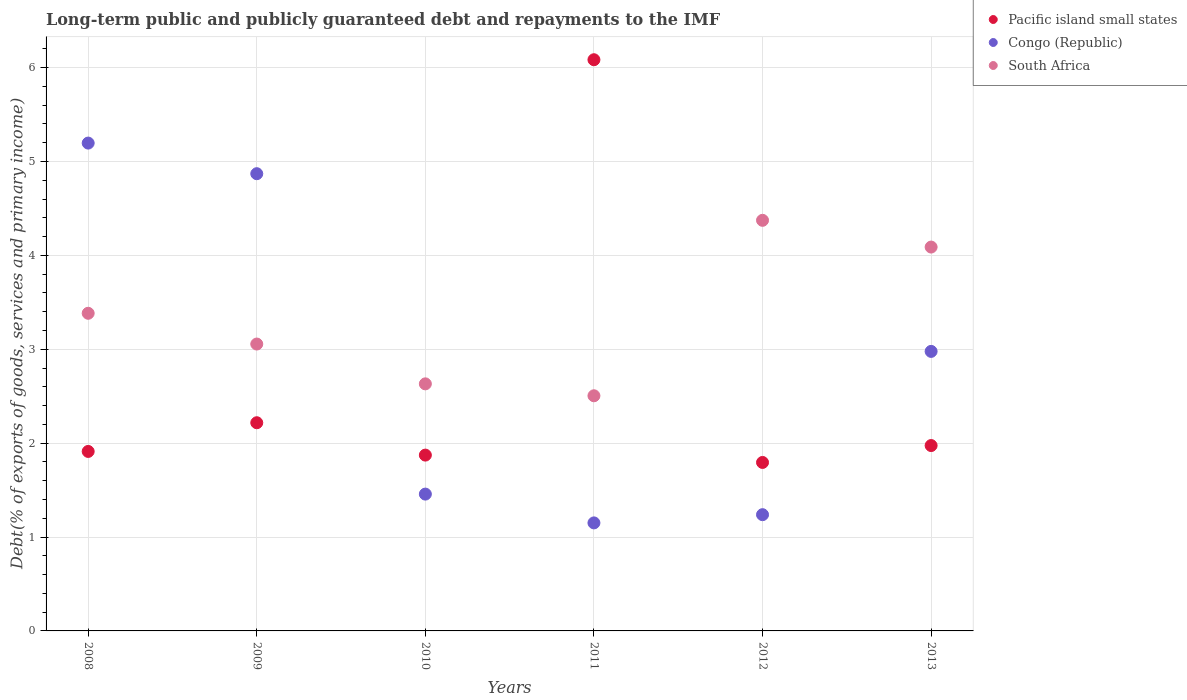Is the number of dotlines equal to the number of legend labels?
Give a very brief answer. Yes. What is the debt and repayments in Pacific island small states in 2012?
Your answer should be very brief. 1.79. Across all years, what is the maximum debt and repayments in Pacific island small states?
Ensure brevity in your answer.  6.08. Across all years, what is the minimum debt and repayments in Congo (Republic)?
Ensure brevity in your answer.  1.15. What is the total debt and repayments in Pacific island small states in the graph?
Give a very brief answer. 15.85. What is the difference between the debt and repayments in Congo (Republic) in 2008 and that in 2010?
Give a very brief answer. 3.74. What is the difference between the debt and repayments in Congo (Republic) in 2010 and the debt and repayments in Pacific island small states in 2008?
Offer a terse response. -0.45. What is the average debt and repayments in Congo (Republic) per year?
Give a very brief answer. 2.81. In the year 2010, what is the difference between the debt and repayments in South Africa and debt and repayments in Pacific island small states?
Make the answer very short. 0.76. In how many years, is the debt and repayments in South Africa greater than 1 %?
Your answer should be compact. 6. What is the ratio of the debt and repayments in Congo (Republic) in 2009 to that in 2012?
Provide a short and direct response. 3.93. Is the debt and repayments in Pacific island small states in 2008 less than that in 2013?
Give a very brief answer. Yes. Is the difference between the debt and repayments in South Africa in 2009 and 2011 greater than the difference between the debt and repayments in Pacific island small states in 2009 and 2011?
Ensure brevity in your answer.  Yes. What is the difference between the highest and the second highest debt and repayments in Pacific island small states?
Your answer should be very brief. 3.87. What is the difference between the highest and the lowest debt and repayments in Pacific island small states?
Offer a terse response. 4.29. Is the debt and repayments in Pacific island small states strictly greater than the debt and repayments in Congo (Republic) over the years?
Provide a short and direct response. No. How many dotlines are there?
Offer a very short reply. 3. Does the graph contain any zero values?
Offer a very short reply. No. How many legend labels are there?
Provide a succinct answer. 3. What is the title of the graph?
Offer a terse response. Long-term public and publicly guaranteed debt and repayments to the IMF. Does "Comoros" appear as one of the legend labels in the graph?
Keep it short and to the point. No. What is the label or title of the Y-axis?
Keep it short and to the point. Debt(% of exports of goods, services and primary income). What is the Debt(% of exports of goods, services and primary income) in Pacific island small states in 2008?
Keep it short and to the point. 1.91. What is the Debt(% of exports of goods, services and primary income) of Congo (Republic) in 2008?
Offer a very short reply. 5.2. What is the Debt(% of exports of goods, services and primary income) in South Africa in 2008?
Ensure brevity in your answer.  3.38. What is the Debt(% of exports of goods, services and primary income) of Pacific island small states in 2009?
Your answer should be compact. 2.22. What is the Debt(% of exports of goods, services and primary income) of Congo (Republic) in 2009?
Make the answer very short. 4.87. What is the Debt(% of exports of goods, services and primary income) in South Africa in 2009?
Your answer should be very brief. 3.06. What is the Debt(% of exports of goods, services and primary income) of Pacific island small states in 2010?
Your answer should be very brief. 1.87. What is the Debt(% of exports of goods, services and primary income) of Congo (Republic) in 2010?
Make the answer very short. 1.46. What is the Debt(% of exports of goods, services and primary income) of South Africa in 2010?
Offer a very short reply. 2.63. What is the Debt(% of exports of goods, services and primary income) of Pacific island small states in 2011?
Make the answer very short. 6.08. What is the Debt(% of exports of goods, services and primary income) in Congo (Republic) in 2011?
Provide a short and direct response. 1.15. What is the Debt(% of exports of goods, services and primary income) in South Africa in 2011?
Give a very brief answer. 2.5. What is the Debt(% of exports of goods, services and primary income) in Pacific island small states in 2012?
Your answer should be compact. 1.79. What is the Debt(% of exports of goods, services and primary income) of Congo (Republic) in 2012?
Give a very brief answer. 1.24. What is the Debt(% of exports of goods, services and primary income) in South Africa in 2012?
Your answer should be compact. 4.37. What is the Debt(% of exports of goods, services and primary income) of Pacific island small states in 2013?
Your response must be concise. 1.97. What is the Debt(% of exports of goods, services and primary income) in Congo (Republic) in 2013?
Keep it short and to the point. 2.98. What is the Debt(% of exports of goods, services and primary income) in South Africa in 2013?
Provide a short and direct response. 4.09. Across all years, what is the maximum Debt(% of exports of goods, services and primary income) of Pacific island small states?
Your answer should be very brief. 6.08. Across all years, what is the maximum Debt(% of exports of goods, services and primary income) in Congo (Republic)?
Offer a very short reply. 5.2. Across all years, what is the maximum Debt(% of exports of goods, services and primary income) of South Africa?
Your response must be concise. 4.37. Across all years, what is the minimum Debt(% of exports of goods, services and primary income) in Pacific island small states?
Your answer should be very brief. 1.79. Across all years, what is the minimum Debt(% of exports of goods, services and primary income) of Congo (Republic)?
Give a very brief answer. 1.15. Across all years, what is the minimum Debt(% of exports of goods, services and primary income) in South Africa?
Offer a terse response. 2.5. What is the total Debt(% of exports of goods, services and primary income) of Pacific island small states in the graph?
Your response must be concise. 15.85. What is the total Debt(% of exports of goods, services and primary income) in Congo (Republic) in the graph?
Provide a succinct answer. 16.89. What is the total Debt(% of exports of goods, services and primary income) of South Africa in the graph?
Your response must be concise. 20.04. What is the difference between the Debt(% of exports of goods, services and primary income) in Pacific island small states in 2008 and that in 2009?
Offer a very short reply. -0.31. What is the difference between the Debt(% of exports of goods, services and primary income) in Congo (Republic) in 2008 and that in 2009?
Offer a terse response. 0.33. What is the difference between the Debt(% of exports of goods, services and primary income) of South Africa in 2008 and that in 2009?
Give a very brief answer. 0.33. What is the difference between the Debt(% of exports of goods, services and primary income) in Pacific island small states in 2008 and that in 2010?
Your answer should be very brief. 0.04. What is the difference between the Debt(% of exports of goods, services and primary income) of Congo (Republic) in 2008 and that in 2010?
Make the answer very short. 3.74. What is the difference between the Debt(% of exports of goods, services and primary income) in South Africa in 2008 and that in 2010?
Keep it short and to the point. 0.75. What is the difference between the Debt(% of exports of goods, services and primary income) in Pacific island small states in 2008 and that in 2011?
Keep it short and to the point. -4.17. What is the difference between the Debt(% of exports of goods, services and primary income) of Congo (Republic) in 2008 and that in 2011?
Offer a very short reply. 4.05. What is the difference between the Debt(% of exports of goods, services and primary income) of South Africa in 2008 and that in 2011?
Provide a short and direct response. 0.88. What is the difference between the Debt(% of exports of goods, services and primary income) of Pacific island small states in 2008 and that in 2012?
Keep it short and to the point. 0.12. What is the difference between the Debt(% of exports of goods, services and primary income) in Congo (Republic) in 2008 and that in 2012?
Give a very brief answer. 3.96. What is the difference between the Debt(% of exports of goods, services and primary income) of South Africa in 2008 and that in 2012?
Your answer should be very brief. -0.99. What is the difference between the Debt(% of exports of goods, services and primary income) in Pacific island small states in 2008 and that in 2013?
Give a very brief answer. -0.06. What is the difference between the Debt(% of exports of goods, services and primary income) of Congo (Republic) in 2008 and that in 2013?
Your answer should be compact. 2.22. What is the difference between the Debt(% of exports of goods, services and primary income) in South Africa in 2008 and that in 2013?
Offer a very short reply. -0.71. What is the difference between the Debt(% of exports of goods, services and primary income) in Pacific island small states in 2009 and that in 2010?
Give a very brief answer. 0.34. What is the difference between the Debt(% of exports of goods, services and primary income) in Congo (Republic) in 2009 and that in 2010?
Provide a short and direct response. 3.41. What is the difference between the Debt(% of exports of goods, services and primary income) in South Africa in 2009 and that in 2010?
Your response must be concise. 0.42. What is the difference between the Debt(% of exports of goods, services and primary income) in Pacific island small states in 2009 and that in 2011?
Provide a short and direct response. -3.87. What is the difference between the Debt(% of exports of goods, services and primary income) of Congo (Republic) in 2009 and that in 2011?
Give a very brief answer. 3.72. What is the difference between the Debt(% of exports of goods, services and primary income) of South Africa in 2009 and that in 2011?
Provide a succinct answer. 0.55. What is the difference between the Debt(% of exports of goods, services and primary income) in Pacific island small states in 2009 and that in 2012?
Ensure brevity in your answer.  0.42. What is the difference between the Debt(% of exports of goods, services and primary income) in Congo (Republic) in 2009 and that in 2012?
Your answer should be compact. 3.63. What is the difference between the Debt(% of exports of goods, services and primary income) in South Africa in 2009 and that in 2012?
Give a very brief answer. -1.32. What is the difference between the Debt(% of exports of goods, services and primary income) of Pacific island small states in 2009 and that in 2013?
Ensure brevity in your answer.  0.24. What is the difference between the Debt(% of exports of goods, services and primary income) of Congo (Republic) in 2009 and that in 2013?
Keep it short and to the point. 1.89. What is the difference between the Debt(% of exports of goods, services and primary income) in South Africa in 2009 and that in 2013?
Your response must be concise. -1.03. What is the difference between the Debt(% of exports of goods, services and primary income) of Pacific island small states in 2010 and that in 2011?
Offer a terse response. -4.21. What is the difference between the Debt(% of exports of goods, services and primary income) of Congo (Republic) in 2010 and that in 2011?
Provide a short and direct response. 0.31. What is the difference between the Debt(% of exports of goods, services and primary income) in South Africa in 2010 and that in 2011?
Your response must be concise. 0.13. What is the difference between the Debt(% of exports of goods, services and primary income) in Pacific island small states in 2010 and that in 2012?
Your response must be concise. 0.08. What is the difference between the Debt(% of exports of goods, services and primary income) of Congo (Republic) in 2010 and that in 2012?
Ensure brevity in your answer.  0.22. What is the difference between the Debt(% of exports of goods, services and primary income) in South Africa in 2010 and that in 2012?
Your answer should be compact. -1.74. What is the difference between the Debt(% of exports of goods, services and primary income) in Pacific island small states in 2010 and that in 2013?
Give a very brief answer. -0.1. What is the difference between the Debt(% of exports of goods, services and primary income) in Congo (Republic) in 2010 and that in 2013?
Give a very brief answer. -1.52. What is the difference between the Debt(% of exports of goods, services and primary income) of South Africa in 2010 and that in 2013?
Make the answer very short. -1.46. What is the difference between the Debt(% of exports of goods, services and primary income) in Pacific island small states in 2011 and that in 2012?
Give a very brief answer. 4.29. What is the difference between the Debt(% of exports of goods, services and primary income) in Congo (Republic) in 2011 and that in 2012?
Your answer should be compact. -0.09. What is the difference between the Debt(% of exports of goods, services and primary income) of South Africa in 2011 and that in 2012?
Your answer should be compact. -1.87. What is the difference between the Debt(% of exports of goods, services and primary income) in Pacific island small states in 2011 and that in 2013?
Provide a succinct answer. 4.11. What is the difference between the Debt(% of exports of goods, services and primary income) of Congo (Republic) in 2011 and that in 2013?
Your answer should be compact. -1.83. What is the difference between the Debt(% of exports of goods, services and primary income) in South Africa in 2011 and that in 2013?
Give a very brief answer. -1.58. What is the difference between the Debt(% of exports of goods, services and primary income) of Pacific island small states in 2012 and that in 2013?
Provide a short and direct response. -0.18. What is the difference between the Debt(% of exports of goods, services and primary income) of Congo (Republic) in 2012 and that in 2013?
Your response must be concise. -1.74. What is the difference between the Debt(% of exports of goods, services and primary income) of South Africa in 2012 and that in 2013?
Keep it short and to the point. 0.28. What is the difference between the Debt(% of exports of goods, services and primary income) in Pacific island small states in 2008 and the Debt(% of exports of goods, services and primary income) in Congo (Republic) in 2009?
Offer a very short reply. -2.96. What is the difference between the Debt(% of exports of goods, services and primary income) in Pacific island small states in 2008 and the Debt(% of exports of goods, services and primary income) in South Africa in 2009?
Your answer should be very brief. -1.14. What is the difference between the Debt(% of exports of goods, services and primary income) of Congo (Republic) in 2008 and the Debt(% of exports of goods, services and primary income) of South Africa in 2009?
Your response must be concise. 2.14. What is the difference between the Debt(% of exports of goods, services and primary income) in Pacific island small states in 2008 and the Debt(% of exports of goods, services and primary income) in Congo (Republic) in 2010?
Give a very brief answer. 0.45. What is the difference between the Debt(% of exports of goods, services and primary income) in Pacific island small states in 2008 and the Debt(% of exports of goods, services and primary income) in South Africa in 2010?
Make the answer very short. -0.72. What is the difference between the Debt(% of exports of goods, services and primary income) in Congo (Republic) in 2008 and the Debt(% of exports of goods, services and primary income) in South Africa in 2010?
Your response must be concise. 2.56. What is the difference between the Debt(% of exports of goods, services and primary income) in Pacific island small states in 2008 and the Debt(% of exports of goods, services and primary income) in Congo (Republic) in 2011?
Your answer should be compact. 0.76. What is the difference between the Debt(% of exports of goods, services and primary income) of Pacific island small states in 2008 and the Debt(% of exports of goods, services and primary income) of South Africa in 2011?
Keep it short and to the point. -0.59. What is the difference between the Debt(% of exports of goods, services and primary income) in Congo (Republic) in 2008 and the Debt(% of exports of goods, services and primary income) in South Africa in 2011?
Provide a short and direct response. 2.69. What is the difference between the Debt(% of exports of goods, services and primary income) in Pacific island small states in 2008 and the Debt(% of exports of goods, services and primary income) in Congo (Republic) in 2012?
Offer a terse response. 0.67. What is the difference between the Debt(% of exports of goods, services and primary income) in Pacific island small states in 2008 and the Debt(% of exports of goods, services and primary income) in South Africa in 2012?
Give a very brief answer. -2.46. What is the difference between the Debt(% of exports of goods, services and primary income) in Congo (Republic) in 2008 and the Debt(% of exports of goods, services and primary income) in South Africa in 2012?
Offer a very short reply. 0.82. What is the difference between the Debt(% of exports of goods, services and primary income) of Pacific island small states in 2008 and the Debt(% of exports of goods, services and primary income) of Congo (Republic) in 2013?
Give a very brief answer. -1.07. What is the difference between the Debt(% of exports of goods, services and primary income) in Pacific island small states in 2008 and the Debt(% of exports of goods, services and primary income) in South Africa in 2013?
Your response must be concise. -2.18. What is the difference between the Debt(% of exports of goods, services and primary income) of Congo (Republic) in 2008 and the Debt(% of exports of goods, services and primary income) of South Africa in 2013?
Ensure brevity in your answer.  1.11. What is the difference between the Debt(% of exports of goods, services and primary income) of Pacific island small states in 2009 and the Debt(% of exports of goods, services and primary income) of Congo (Republic) in 2010?
Your answer should be very brief. 0.76. What is the difference between the Debt(% of exports of goods, services and primary income) in Pacific island small states in 2009 and the Debt(% of exports of goods, services and primary income) in South Africa in 2010?
Your answer should be compact. -0.41. What is the difference between the Debt(% of exports of goods, services and primary income) of Congo (Republic) in 2009 and the Debt(% of exports of goods, services and primary income) of South Africa in 2010?
Give a very brief answer. 2.24. What is the difference between the Debt(% of exports of goods, services and primary income) in Pacific island small states in 2009 and the Debt(% of exports of goods, services and primary income) in Congo (Republic) in 2011?
Your answer should be very brief. 1.07. What is the difference between the Debt(% of exports of goods, services and primary income) of Pacific island small states in 2009 and the Debt(% of exports of goods, services and primary income) of South Africa in 2011?
Give a very brief answer. -0.29. What is the difference between the Debt(% of exports of goods, services and primary income) in Congo (Republic) in 2009 and the Debt(% of exports of goods, services and primary income) in South Africa in 2011?
Offer a terse response. 2.37. What is the difference between the Debt(% of exports of goods, services and primary income) of Pacific island small states in 2009 and the Debt(% of exports of goods, services and primary income) of Congo (Republic) in 2012?
Offer a terse response. 0.98. What is the difference between the Debt(% of exports of goods, services and primary income) in Pacific island small states in 2009 and the Debt(% of exports of goods, services and primary income) in South Africa in 2012?
Your answer should be very brief. -2.16. What is the difference between the Debt(% of exports of goods, services and primary income) in Congo (Republic) in 2009 and the Debt(% of exports of goods, services and primary income) in South Africa in 2012?
Provide a succinct answer. 0.5. What is the difference between the Debt(% of exports of goods, services and primary income) of Pacific island small states in 2009 and the Debt(% of exports of goods, services and primary income) of Congo (Republic) in 2013?
Your answer should be compact. -0.76. What is the difference between the Debt(% of exports of goods, services and primary income) of Pacific island small states in 2009 and the Debt(% of exports of goods, services and primary income) of South Africa in 2013?
Keep it short and to the point. -1.87. What is the difference between the Debt(% of exports of goods, services and primary income) in Congo (Republic) in 2009 and the Debt(% of exports of goods, services and primary income) in South Africa in 2013?
Provide a succinct answer. 0.78. What is the difference between the Debt(% of exports of goods, services and primary income) of Pacific island small states in 2010 and the Debt(% of exports of goods, services and primary income) of Congo (Republic) in 2011?
Provide a succinct answer. 0.72. What is the difference between the Debt(% of exports of goods, services and primary income) of Pacific island small states in 2010 and the Debt(% of exports of goods, services and primary income) of South Africa in 2011?
Provide a short and direct response. -0.63. What is the difference between the Debt(% of exports of goods, services and primary income) in Congo (Republic) in 2010 and the Debt(% of exports of goods, services and primary income) in South Africa in 2011?
Ensure brevity in your answer.  -1.05. What is the difference between the Debt(% of exports of goods, services and primary income) in Pacific island small states in 2010 and the Debt(% of exports of goods, services and primary income) in Congo (Republic) in 2012?
Give a very brief answer. 0.63. What is the difference between the Debt(% of exports of goods, services and primary income) of Pacific island small states in 2010 and the Debt(% of exports of goods, services and primary income) of South Africa in 2012?
Make the answer very short. -2.5. What is the difference between the Debt(% of exports of goods, services and primary income) in Congo (Republic) in 2010 and the Debt(% of exports of goods, services and primary income) in South Africa in 2012?
Your response must be concise. -2.92. What is the difference between the Debt(% of exports of goods, services and primary income) of Pacific island small states in 2010 and the Debt(% of exports of goods, services and primary income) of Congo (Republic) in 2013?
Keep it short and to the point. -1.1. What is the difference between the Debt(% of exports of goods, services and primary income) in Pacific island small states in 2010 and the Debt(% of exports of goods, services and primary income) in South Africa in 2013?
Offer a very short reply. -2.22. What is the difference between the Debt(% of exports of goods, services and primary income) of Congo (Republic) in 2010 and the Debt(% of exports of goods, services and primary income) of South Africa in 2013?
Make the answer very short. -2.63. What is the difference between the Debt(% of exports of goods, services and primary income) in Pacific island small states in 2011 and the Debt(% of exports of goods, services and primary income) in Congo (Republic) in 2012?
Provide a short and direct response. 4.85. What is the difference between the Debt(% of exports of goods, services and primary income) in Pacific island small states in 2011 and the Debt(% of exports of goods, services and primary income) in South Africa in 2012?
Provide a succinct answer. 1.71. What is the difference between the Debt(% of exports of goods, services and primary income) of Congo (Republic) in 2011 and the Debt(% of exports of goods, services and primary income) of South Africa in 2012?
Provide a short and direct response. -3.22. What is the difference between the Debt(% of exports of goods, services and primary income) of Pacific island small states in 2011 and the Debt(% of exports of goods, services and primary income) of Congo (Republic) in 2013?
Make the answer very short. 3.11. What is the difference between the Debt(% of exports of goods, services and primary income) in Pacific island small states in 2011 and the Debt(% of exports of goods, services and primary income) in South Africa in 2013?
Make the answer very short. 2. What is the difference between the Debt(% of exports of goods, services and primary income) in Congo (Republic) in 2011 and the Debt(% of exports of goods, services and primary income) in South Africa in 2013?
Offer a very short reply. -2.94. What is the difference between the Debt(% of exports of goods, services and primary income) of Pacific island small states in 2012 and the Debt(% of exports of goods, services and primary income) of Congo (Republic) in 2013?
Your answer should be compact. -1.18. What is the difference between the Debt(% of exports of goods, services and primary income) in Pacific island small states in 2012 and the Debt(% of exports of goods, services and primary income) in South Africa in 2013?
Give a very brief answer. -2.29. What is the difference between the Debt(% of exports of goods, services and primary income) of Congo (Republic) in 2012 and the Debt(% of exports of goods, services and primary income) of South Africa in 2013?
Provide a succinct answer. -2.85. What is the average Debt(% of exports of goods, services and primary income) in Pacific island small states per year?
Ensure brevity in your answer.  2.64. What is the average Debt(% of exports of goods, services and primary income) of Congo (Republic) per year?
Ensure brevity in your answer.  2.81. What is the average Debt(% of exports of goods, services and primary income) in South Africa per year?
Provide a succinct answer. 3.34. In the year 2008, what is the difference between the Debt(% of exports of goods, services and primary income) of Pacific island small states and Debt(% of exports of goods, services and primary income) of Congo (Republic)?
Offer a very short reply. -3.28. In the year 2008, what is the difference between the Debt(% of exports of goods, services and primary income) in Pacific island small states and Debt(% of exports of goods, services and primary income) in South Africa?
Keep it short and to the point. -1.47. In the year 2008, what is the difference between the Debt(% of exports of goods, services and primary income) in Congo (Republic) and Debt(% of exports of goods, services and primary income) in South Africa?
Provide a short and direct response. 1.81. In the year 2009, what is the difference between the Debt(% of exports of goods, services and primary income) in Pacific island small states and Debt(% of exports of goods, services and primary income) in Congo (Republic)?
Make the answer very short. -2.65. In the year 2009, what is the difference between the Debt(% of exports of goods, services and primary income) in Pacific island small states and Debt(% of exports of goods, services and primary income) in South Africa?
Offer a terse response. -0.84. In the year 2009, what is the difference between the Debt(% of exports of goods, services and primary income) of Congo (Republic) and Debt(% of exports of goods, services and primary income) of South Africa?
Ensure brevity in your answer.  1.81. In the year 2010, what is the difference between the Debt(% of exports of goods, services and primary income) of Pacific island small states and Debt(% of exports of goods, services and primary income) of Congo (Republic)?
Offer a terse response. 0.42. In the year 2010, what is the difference between the Debt(% of exports of goods, services and primary income) in Pacific island small states and Debt(% of exports of goods, services and primary income) in South Africa?
Your answer should be very brief. -0.76. In the year 2010, what is the difference between the Debt(% of exports of goods, services and primary income) of Congo (Republic) and Debt(% of exports of goods, services and primary income) of South Africa?
Keep it short and to the point. -1.17. In the year 2011, what is the difference between the Debt(% of exports of goods, services and primary income) of Pacific island small states and Debt(% of exports of goods, services and primary income) of Congo (Republic)?
Ensure brevity in your answer.  4.93. In the year 2011, what is the difference between the Debt(% of exports of goods, services and primary income) of Pacific island small states and Debt(% of exports of goods, services and primary income) of South Africa?
Keep it short and to the point. 3.58. In the year 2011, what is the difference between the Debt(% of exports of goods, services and primary income) of Congo (Republic) and Debt(% of exports of goods, services and primary income) of South Africa?
Provide a succinct answer. -1.35. In the year 2012, what is the difference between the Debt(% of exports of goods, services and primary income) of Pacific island small states and Debt(% of exports of goods, services and primary income) of Congo (Republic)?
Offer a terse response. 0.56. In the year 2012, what is the difference between the Debt(% of exports of goods, services and primary income) of Pacific island small states and Debt(% of exports of goods, services and primary income) of South Africa?
Offer a terse response. -2.58. In the year 2012, what is the difference between the Debt(% of exports of goods, services and primary income) in Congo (Republic) and Debt(% of exports of goods, services and primary income) in South Africa?
Your answer should be compact. -3.14. In the year 2013, what is the difference between the Debt(% of exports of goods, services and primary income) of Pacific island small states and Debt(% of exports of goods, services and primary income) of Congo (Republic)?
Your response must be concise. -1. In the year 2013, what is the difference between the Debt(% of exports of goods, services and primary income) of Pacific island small states and Debt(% of exports of goods, services and primary income) of South Africa?
Provide a succinct answer. -2.11. In the year 2013, what is the difference between the Debt(% of exports of goods, services and primary income) in Congo (Republic) and Debt(% of exports of goods, services and primary income) in South Africa?
Ensure brevity in your answer.  -1.11. What is the ratio of the Debt(% of exports of goods, services and primary income) of Pacific island small states in 2008 to that in 2009?
Keep it short and to the point. 0.86. What is the ratio of the Debt(% of exports of goods, services and primary income) in Congo (Republic) in 2008 to that in 2009?
Offer a terse response. 1.07. What is the ratio of the Debt(% of exports of goods, services and primary income) in South Africa in 2008 to that in 2009?
Your answer should be compact. 1.11. What is the ratio of the Debt(% of exports of goods, services and primary income) in Pacific island small states in 2008 to that in 2010?
Provide a short and direct response. 1.02. What is the ratio of the Debt(% of exports of goods, services and primary income) of Congo (Republic) in 2008 to that in 2010?
Give a very brief answer. 3.57. What is the ratio of the Debt(% of exports of goods, services and primary income) of South Africa in 2008 to that in 2010?
Provide a succinct answer. 1.29. What is the ratio of the Debt(% of exports of goods, services and primary income) in Pacific island small states in 2008 to that in 2011?
Give a very brief answer. 0.31. What is the ratio of the Debt(% of exports of goods, services and primary income) of Congo (Republic) in 2008 to that in 2011?
Offer a terse response. 4.52. What is the ratio of the Debt(% of exports of goods, services and primary income) in South Africa in 2008 to that in 2011?
Offer a very short reply. 1.35. What is the ratio of the Debt(% of exports of goods, services and primary income) of Pacific island small states in 2008 to that in 2012?
Your response must be concise. 1.07. What is the ratio of the Debt(% of exports of goods, services and primary income) of Congo (Republic) in 2008 to that in 2012?
Provide a short and direct response. 4.2. What is the ratio of the Debt(% of exports of goods, services and primary income) in South Africa in 2008 to that in 2012?
Keep it short and to the point. 0.77. What is the ratio of the Debt(% of exports of goods, services and primary income) in Pacific island small states in 2008 to that in 2013?
Give a very brief answer. 0.97. What is the ratio of the Debt(% of exports of goods, services and primary income) in Congo (Republic) in 2008 to that in 2013?
Ensure brevity in your answer.  1.75. What is the ratio of the Debt(% of exports of goods, services and primary income) of South Africa in 2008 to that in 2013?
Your response must be concise. 0.83. What is the ratio of the Debt(% of exports of goods, services and primary income) in Pacific island small states in 2009 to that in 2010?
Offer a very short reply. 1.18. What is the ratio of the Debt(% of exports of goods, services and primary income) in Congo (Republic) in 2009 to that in 2010?
Ensure brevity in your answer.  3.34. What is the ratio of the Debt(% of exports of goods, services and primary income) in South Africa in 2009 to that in 2010?
Keep it short and to the point. 1.16. What is the ratio of the Debt(% of exports of goods, services and primary income) of Pacific island small states in 2009 to that in 2011?
Provide a short and direct response. 0.36. What is the ratio of the Debt(% of exports of goods, services and primary income) of Congo (Republic) in 2009 to that in 2011?
Your answer should be very brief. 4.23. What is the ratio of the Debt(% of exports of goods, services and primary income) in South Africa in 2009 to that in 2011?
Your response must be concise. 1.22. What is the ratio of the Debt(% of exports of goods, services and primary income) of Pacific island small states in 2009 to that in 2012?
Keep it short and to the point. 1.24. What is the ratio of the Debt(% of exports of goods, services and primary income) in Congo (Republic) in 2009 to that in 2012?
Offer a terse response. 3.93. What is the ratio of the Debt(% of exports of goods, services and primary income) in South Africa in 2009 to that in 2012?
Provide a succinct answer. 0.7. What is the ratio of the Debt(% of exports of goods, services and primary income) in Pacific island small states in 2009 to that in 2013?
Make the answer very short. 1.12. What is the ratio of the Debt(% of exports of goods, services and primary income) in Congo (Republic) in 2009 to that in 2013?
Keep it short and to the point. 1.64. What is the ratio of the Debt(% of exports of goods, services and primary income) in South Africa in 2009 to that in 2013?
Your response must be concise. 0.75. What is the ratio of the Debt(% of exports of goods, services and primary income) of Pacific island small states in 2010 to that in 2011?
Provide a short and direct response. 0.31. What is the ratio of the Debt(% of exports of goods, services and primary income) in Congo (Republic) in 2010 to that in 2011?
Offer a terse response. 1.27. What is the ratio of the Debt(% of exports of goods, services and primary income) in South Africa in 2010 to that in 2011?
Ensure brevity in your answer.  1.05. What is the ratio of the Debt(% of exports of goods, services and primary income) in Pacific island small states in 2010 to that in 2012?
Your response must be concise. 1.04. What is the ratio of the Debt(% of exports of goods, services and primary income) in Congo (Republic) in 2010 to that in 2012?
Keep it short and to the point. 1.18. What is the ratio of the Debt(% of exports of goods, services and primary income) of South Africa in 2010 to that in 2012?
Provide a short and direct response. 0.6. What is the ratio of the Debt(% of exports of goods, services and primary income) in Pacific island small states in 2010 to that in 2013?
Offer a terse response. 0.95. What is the ratio of the Debt(% of exports of goods, services and primary income) of Congo (Republic) in 2010 to that in 2013?
Your response must be concise. 0.49. What is the ratio of the Debt(% of exports of goods, services and primary income) of South Africa in 2010 to that in 2013?
Offer a terse response. 0.64. What is the ratio of the Debt(% of exports of goods, services and primary income) of Pacific island small states in 2011 to that in 2012?
Offer a very short reply. 3.39. What is the ratio of the Debt(% of exports of goods, services and primary income) of Congo (Republic) in 2011 to that in 2012?
Offer a very short reply. 0.93. What is the ratio of the Debt(% of exports of goods, services and primary income) of South Africa in 2011 to that in 2012?
Your response must be concise. 0.57. What is the ratio of the Debt(% of exports of goods, services and primary income) in Pacific island small states in 2011 to that in 2013?
Provide a succinct answer. 3.08. What is the ratio of the Debt(% of exports of goods, services and primary income) in Congo (Republic) in 2011 to that in 2013?
Make the answer very short. 0.39. What is the ratio of the Debt(% of exports of goods, services and primary income) of South Africa in 2011 to that in 2013?
Make the answer very short. 0.61. What is the ratio of the Debt(% of exports of goods, services and primary income) in Pacific island small states in 2012 to that in 2013?
Provide a short and direct response. 0.91. What is the ratio of the Debt(% of exports of goods, services and primary income) of Congo (Republic) in 2012 to that in 2013?
Your answer should be compact. 0.42. What is the ratio of the Debt(% of exports of goods, services and primary income) of South Africa in 2012 to that in 2013?
Your answer should be very brief. 1.07. What is the difference between the highest and the second highest Debt(% of exports of goods, services and primary income) in Pacific island small states?
Offer a very short reply. 3.87. What is the difference between the highest and the second highest Debt(% of exports of goods, services and primary income) of Congo (Republic)?
Offer a very short reply. 0.33. What is the difference between the highest and the second highest Debt(% of exports of goods, services and primary income) in South Africa?
Your answer should be compact. 0.28. What is the difference between the highest and the lowest Debt(% of exports of goods, services and primary income) in Pacific island small states?
Your answer should be very brief. 4.29. What is the difference between the highest and the lowest Debt(% of exports of goods, services and primary income) of Congo (Republic)?
Offer a very short reply. 4.05. What is the difference between the highest and the lowest Debt(% of exports of goods, services and primary income) in South Africa?
Keep it short and to the point. 1.87. 